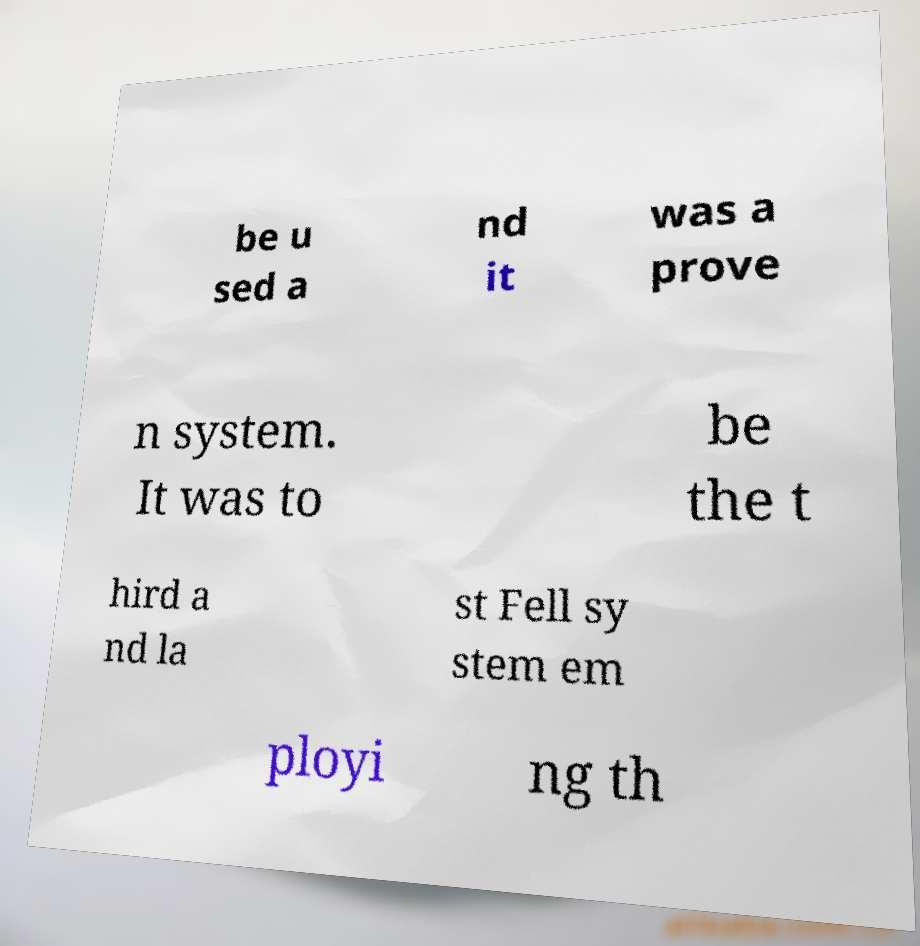What messages or text are displayed in this image? I need them in a readable, typed format. be u sed a nd it was a prove n system. It was to be the t hird a nd la st Fell sy stem em ployi ng th 